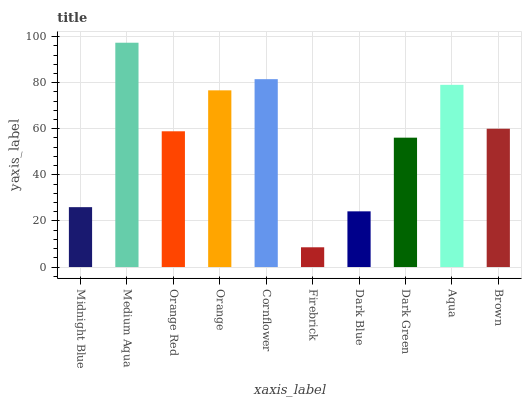Is Firebrick the minimum?
Answer yes or no. Yes. Is Medium Aqua the maximum?
Answer yes or no. Yes. Is Orange Red the minimum?
Answer yes or no. No. Is Orange Red the maximum?
Answer yes or no. No. Is Medium Aqua greater than Orange Red?
Answer yes or no. Yes. Is Orange Red less than Medium Aqua?
Answer yes or no. Yes. Is Orange Red greater than Medium Aqua?
Answer yes or no. No. Is Medium Aqua less than Orange Red?
Answer yes or no. No. Is Brown the high median?
Answer yes or no. Yes. Is Orange Red the low median?
Answer yes or no. Yes. Is Midnight Blue the high median?
Answer yes or no. No. Is Aqua the low median?
Answer yes or no. No. 